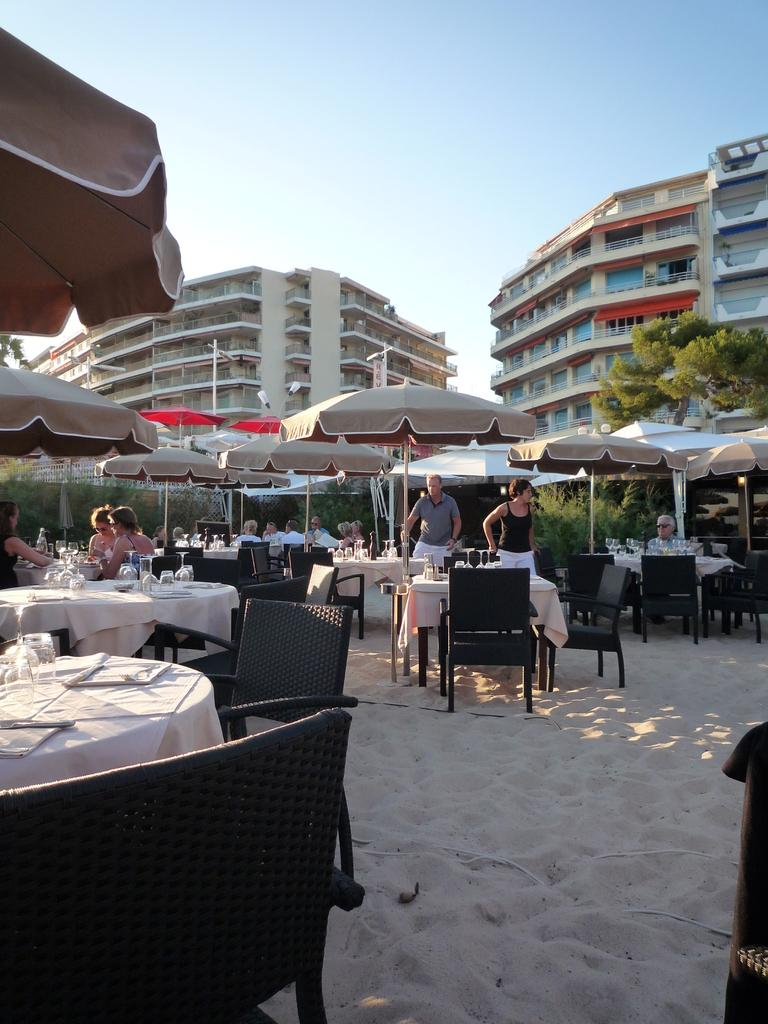What type of furniture is present in the image? There are tables and chairs in the image. What is covering the tables in the image? There are grey tents above the tables. What might be the purpose of the location in the image? The location might be a restaurant. What can be seen in the background of the image? There are buildings and trees visible in the background. How many questions are being asked in the image? There are no questions visible in the image; it is a photograph of a location with tables, chairs, grey tents, buildings, and trees. Is there a boy present in the image? There is no boy visible in the image. 